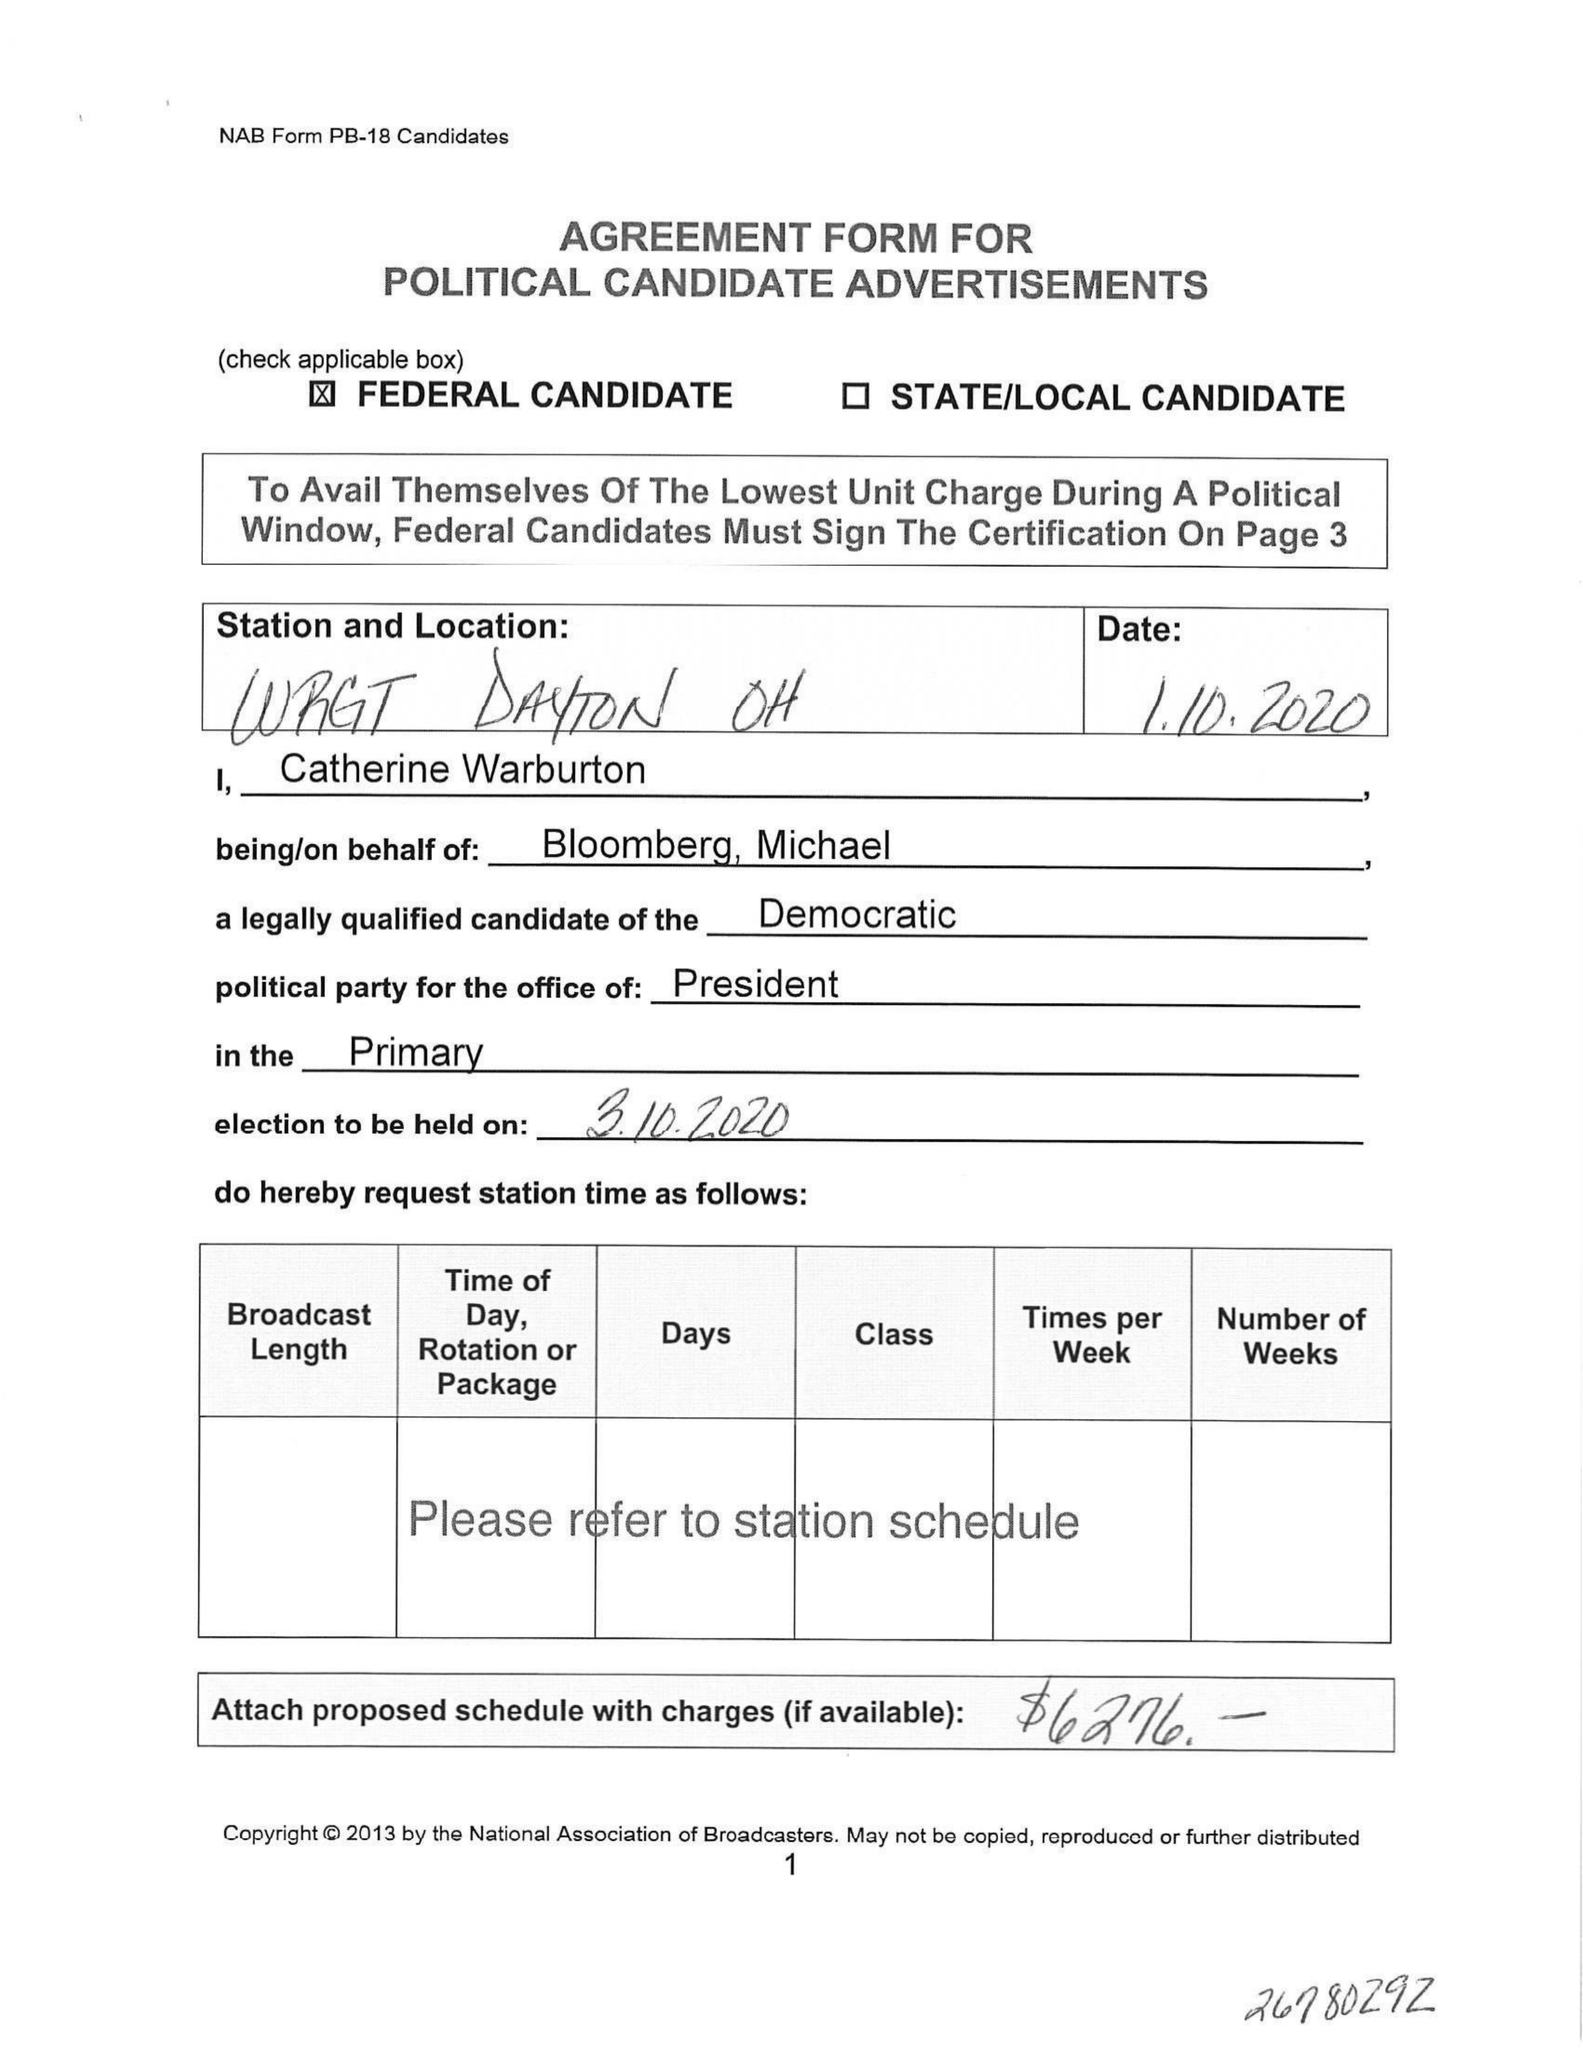What is the value for the flight_from?
Answer the question using a single word or phrase. None 